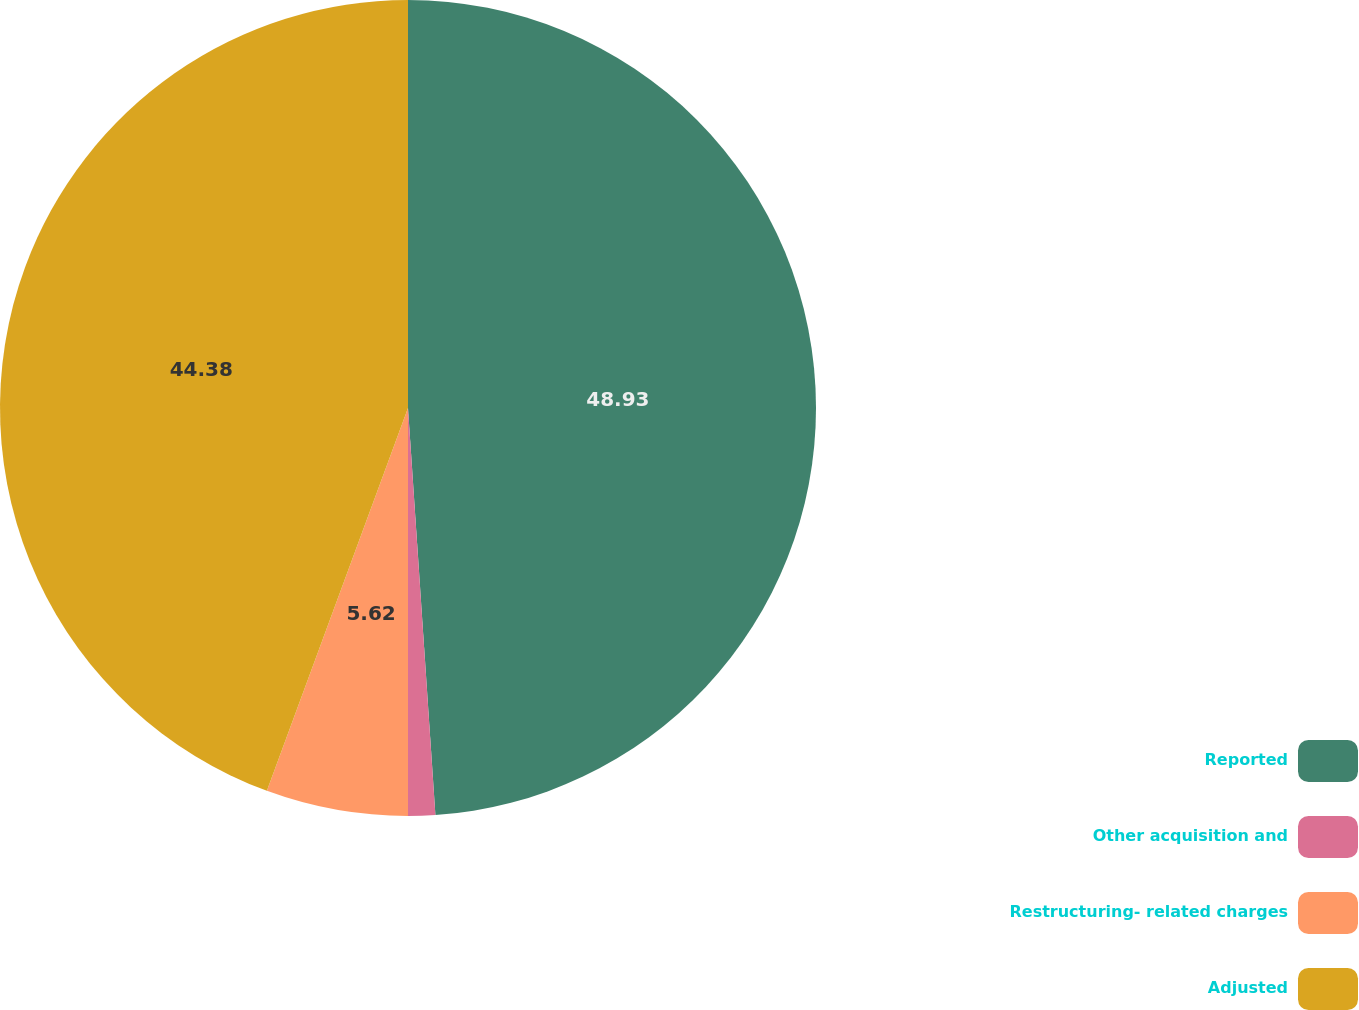Convert chart. <chart><loc_0><loc_0><loc_500><loc_500><pie_chart><fcel>Reported<fcel>Other acquisition and<fcel>Restructuring- related charges<fcel>Adjusted<nl><fcel>48.93%<fcel>1.07%<fcel>5.62%<fcel>44.38%<nl></chart> 